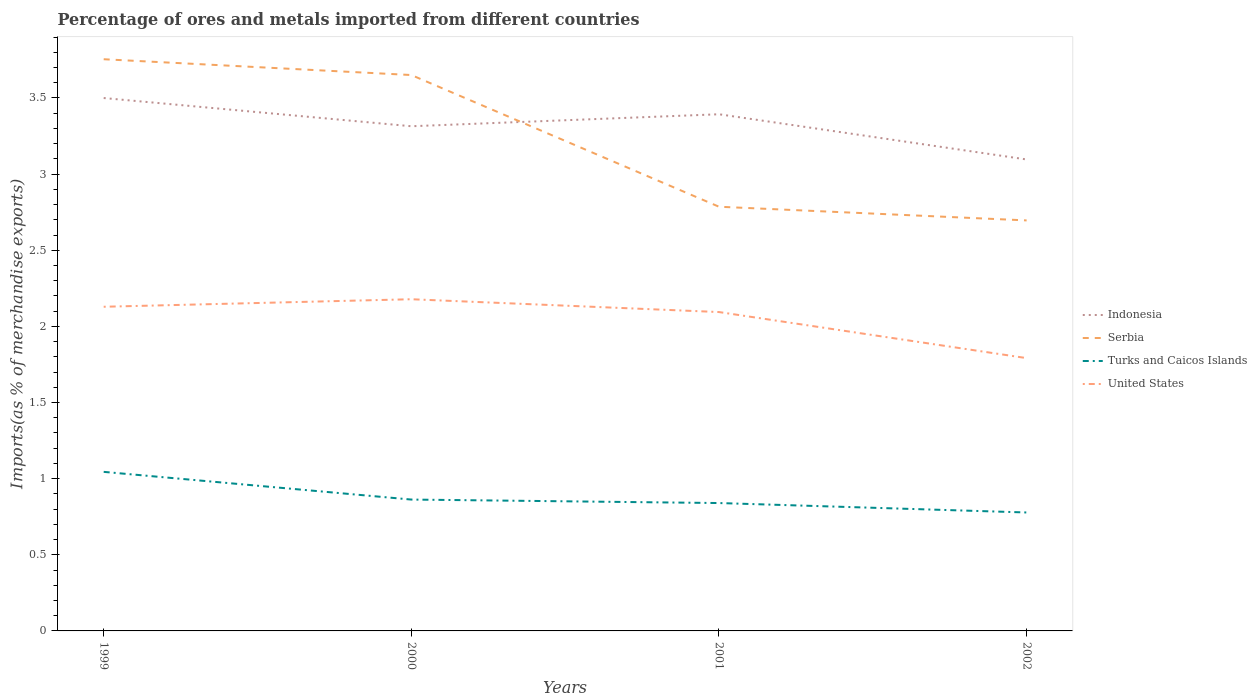How many different coloured lines are there?
Ensure brevity in your answer.  4. Does the line corresponding to Indonesia intersect with the line corresponding to Turks and Caicos Islands?
Your answer should be compact. No. Across all years, what is the maximum percentage of imports to different countries in United States?
Keep it short and to the point. 1.79. In which year was the percentage of imports to different countries in Serbia maximum?
Ensure brevity in your answer.  2002. What is the total percentage of imports to different countries in Turks and Caicos Islands in the graph?
Provide a succinct answer. 0.27. What is the difference between the highest and the second highest percentage of imports to different countries in Serbia?
Offer a terse response. 1.06. How many lines are there?
Offer a very short reply. 4. What is the difference between two consecutive major ticks on the Y-axis?
Provide a succinct answer. 0.5. Are the values on the major ticks of Y-axis written in scientific E-notation?
Offer a terse response. No. Does the graph contain any zero values?
Your response must be concise. No. Does the graph contain grids?
Offer a terse response. No. Where does the legend appear in the graph?
Provide a succinct answer. Center right. What is the title of the graph?
Ensure brevity in your answer.  Percentage of ores and metals imported from different countries. Does "United Kingdom" appear as one of the legend labels in the graph?
Your response must be concise. No. What is the label or title of the X-axis?
Offer a very short reply. Years. What is the label or title of the Y-axis?
Give a very brief answer. Imports(as % of merchandise exports). What is the Imports(as % of merchandise exports) of Indonesia in 1999?
Keep it short and to the point. 3.5. What is the Imports(as % of merchandise exports) in Serbia in 1999?
Ensure brevity in your answer.  3.75. What is the Imports(as % of merchandise exports) in Turks and Caicos Islands in 1999?
Your answer should be very brief. 1.04. What is the Imports(as % of merchandise exports) of United States in 1999?
Give a very brief answer. 2.13. What is the Imports(as % of merchandise exports) of Indonesia in 2000?
Ensure brevity in your answer.  3.31. What is the Imports(as % of merchandise exports) in Serbia in 2000?
Make the answer very short. 3.65. What is the Imports(as % of merchandise exports) in Turks and Caicos Islands in 2000?
Your answer should be compact. 0.86. What is the Imports(as % of merchandise exports) in United States in 2000?
Your answer should be compact. 2.18. What is the Imports(as % of merchandise exports) in Indonesia in 2001?
Provide a short and direct response. 3.39. What is the Imports(as % of merchandise exports) of Serbia in 2001?
Make the answer very short. 2.79. What is the Imports(as % of merchandise exports) of Turks and Caicos Islands in 2001?
Provide a succinct answer. 0.84. What is the Imports(as % of merchandise exports) in United States in 2001?
Ensure brevity in your answer.  2.09. What is the Imports(as % of merchandise exports) of Indonesia in 2002?
Offer a terse response. 3.1. What is the Imports(as % of merchandise exports) of Serbia in 2002?
Offer a terse response. 2.7. What is the Imports(as % of merchandise exports) of Turks and Caicos Islands in 2002?
Ensure brevity in your answer.  0.78. What is the Imports(as % of merchandise exports) in United States in 2002?
Offer a very short reply. 1.79. Across all years, what is the maximum Imports(as % of merchandise exports) in Indonesia?
Your answer should be compact. 3.5. Across all years, what is the maximum Imports(as % of merchandise exports) in Serbia?
Make the answer very short. 3.75. Across all years, what is the maximum Imports(as % of merchandise exports) of Turks and Caicos Islands?
Ensure brevity in your answer.  1.04. Across all years, what is the maximum Imports(as % of merchandise exports) in United States?
Make the answer very short. 2.18. Across all years, what is the minimum Imports(as % of merchandise exports) in Indonesia?
Provide a short and direct response. 3.1. Across all years, what is the minimum Imports(as % of merchandise exports) in Serbia?
Give a very brief answer. 2.7. Across all years, what is the minimum Imports(as % of merchandise exports) in Turks and Caicos Islands?
Ensure brevity in your answer.  0.78. Across all years, what is the minimum Imports(as % of merchandise exports) in United States?
Your answer should be compact. 1.79. What is the total Imports(as % of merchandise exports) of Indonesia in the graph?
Provide a succinct answer. 13.3. What is the total Imports(as % of merchandise exports) in Serbia in the graph?
Make the answer very short. 12.89. What is the total Imports(as % of merchandise exports) of Turks and Caicos Islands in the graph?
Your answer should be very brief. 3.52. What is the total Imports(as % of merchandise exports) in United States in the graph?
Your answer should be compact. 8.19. What is the difference between the Imports(as % of merchandise exports) in Indonesia in 1999 and that in 2000?
Your response must be concise. 0.19. What is the difference between the Imports(as % of merchandise exports) in Serbia in 1999 and that in 2000?
Ensure brevity in your answer.  0.1. What is the difference between the Imports(as % of merchandise exports) of Turks and Caicos Islands in 1999 and that in 2000?
Give a very brief answer. 0.18. What is the difference between the Imports(as % of merchandise exports) in United States in 1999 and that in 2000?
Make the answer very short. -0.05. What is the difference between the Imports(as % of merchandise exports) of Indonesia in 1999 and that in 2001?
Your answer should be very brief. 0.11. What is the difference between the Imports(as % of merchandise exports) in Serbia in 1999 and that in 2001?
Offer a very short reply. 0.97. What is the difference between the Imports(as % of merchandise exports) in Turks and Caicos Islands in 1999 and that in 2001?
Your response must be concise. 0.2. What is the difference between the Imports(as % of merchandise exports) of United States in 1999 and that in 2001?
Provide a succinct answer. 0.03. What is the difference between the Imports(as % of merchandise exports) in Indonesia in 1999 and that in 2002?
Provide a short and direct response. 0.4. What is the difference between the Imports(as % of merchandise exports) of Serbia in 1999 and that in 2002?
Provide a short and direct response. 1.06. What is the difference between the Imports(as % of merchandise exports) in Turks and Caicos Islands in 1999 and that in 2002?
Your response must be concise. 0.27. What is the difference between the Imports(as % of merchandise exports) of United States in 1999 and that in 2002?
Your response must be concise. 0.34. What is the difference between the Imports(as % of merchandise exports) of Indonesia in 2000 and that in 2001?
Your response must be concise. -0.08. What is the difference between the Imports(as % of merchandise exports) in Serbia in 2000 and that in 2001?
Ensure brevity in your answer.  0.86. What is the difference between the Imports(as % of merchandise exports) of Turks and Caicos Islands in 2000 and that in 2001?
Provide a short and direct response. 0.02. What is the difference between the Imports(as % of merchandise exports) of United States in 2000 and that in 2001?
Offer a very short reply. 0.08. What is the difference between the Imports(as % of merchandise exports) in Indonesia in 2000 and that in 2002?
Provide a succinct answer. 0.22. What is the difference between the Imports(as % of merchandise exports) in Serbia in 2000 and that in 2002?
Your response must be concise. 0.95. What is the difference between the Imports(as % of merchandise exports) of Turks and Caicos Islands in 2000 and that in 2002?
Your answer should be very brief. 0.08. What is the difference between the Imports(as % of merchandise exports) in United States in 2000 and that in 2002?
Provide a short and direct response. 0.39. What is the difference between the Imports(as % of merchandise exports) of Indonesia in 2001 and that in 2002?
Your answer should be compact. 0.3. What is the difference between the Imports(as % of merchandise exports) of Serbia in 2001 and that in 2002?
Your response must be concise. 0.09. What is the difference between the Imports(as % of merchandise exports) of Turks and Caicos Islands in 2001 and that in 2002?
Give a very brief answer. 0.06. What is the difference between the Imports(as % of merchandise exports) of United States in 2001 and that in 2002?
Your answer should be compact. 0.3. What is the difference between the Imports(as % of merchandise exports) in Indonesia in 1999 and the Imports(as % of merchandise exports) in Serbia in 2000?
Keep it short and to the point. -0.15. What is the difference between the Imports(as % of merchandise exports) of Indonesia in 1999 and the Imports(as % of merchandise exports) of Turks and Caicos Islands in 2000?
Your answer should be compact. 2.64. What is the difference between the Imports(as % of merchandise exports) in Indonesia in 1999 and the Imports(as % of merchandise exports) in United States in 2000?
Your answer should be very brief. 1.32. What is the difference between the Imports(as % of merchandise exports) in Serbia in 1999 and the Imports(as % of merchandise exports) in Turks and Caicos Islands in 2000?
Keep it short and to the point. 2.89. What is the difference between the Imports(as % of merchandise exports) in Serbia in 1999 and the Imports(as % of merchandise exports) in United States in 2000?
Ensure brevity in your answer.  1.58. What is the difference between the Imports(as % of merchandise exports) of Turks and Caicos Islands in 1999 and the Imports(as % of merchandise exports) of United States in 2000?
Your answer should be very brief. -1.13. What is the difference between the Imports(as % of merchandise exports) in Indonesia in 1999 and the Imports(as % of merchandise exports) in Serbia in 2001?
Give a very brief answer. 0.71. What is the difference between the Imports(as % of merchandise exports) in Indonesia in 1999 and the Imports(as % of merchandise exports) in Turks and Caicos Islands in 2001?
Give a very brief answer. 2.66. What is the difference between the Imports(as % of merchandise exports) of Indonesia in 1999 and the Imports(as % of merchandise exports) of United States in 2001?
Your answer should be very brief. 1.41. What is the difference between the Imports(as % of merchandise exports) in Serbia in 1999 and the Imports(as % of merchandise exports) in Turks and Caicos Islands in 2001?
Offer a terse response. 2.91. What is the difference between the Imports(as % of merchandise exports) of Serbia in 1999 and the Imports(as % of merchandise exports) of United States in 2001?
Your response must be concise. 1.66. What is the difference between the Imports(as % of merchandise exports) of Turks and Caicos Islands in 1999 and the Imports(as % of merchandise exports) of United States in 2001?
Make the answer very short. -1.05. What is the difference between the Imports(as % of merchandise exports) in Indonesia in 1999 and the Imports(as % of merchandise exports) in Serbia in 2002?
Keep it short and to the point. 0.8. What is the difference between the Imports(as % of merchandise exports) of Indonesia in 1999 and the Imports(as % of merchandise exports) of Turks and Caicos Islands in 2002?
Make the answer very short. 2.72. What is the difference between the Imports(as % of merchandise exports) in Indonesia in 1999 and the Imports(as % of merchandise exports) in United States in 2002?
Give a very brief answer. 1.71. What is the difference between the Imports(as % of merchandise exports) of Serbia in 1999 and the Imports(as % of merchandise exports) of Turks and Caicos Islands in 2002?
Keep it short and to the point. 2.98. What is the difference between the Imports(as % of merchandise exports) of Serbia in 1999 and the Imports(as % of merchandise exports) of United States in 2002?
Provide a short and direct response. 1.96. What is the difference between the Imports(as % of merchandise exports) of Turks and Caicos Islands in 1999 and the Imports(as % of merchandise exports) of United States in 2002?
Your answer should be very brief. -0.75. What is the difference between the Imports(as % of merchandise exports) of Indonesia in 2000 and the Imports(as % of merchandise exports) of Serbia in 2001?
Provide a short and direct response. 0.53. What is the difference between the Imports(as % of merchandise exports) of Indonesia in 2000 and the Imports(as % of merchandise exports) of Turks and Caicos Islands in 2001?
Keep it short and to the point. 2.47. What is the difference between the Imports(as % of merchandise exports) in Indonesia in 2000 and the Imports(as % of merchandise exports) in United States in 2001?
Your answer should be very brief. 1.22. What is the difference between the Imports(as % of merchandise exports) in Serbia in 2000 and the Imports(as % of merchandise exports) in Turks and Caicos Islands in 2001?
Provide a short and direct response. 2.81. What is the difference between the Imports(as % of merchandise exports) in Serbia in 2000 and the Imports(as % of merchandise exports) in United States in 2001?
Give a very brief answer. 1.56. What is the difference between the Imports(as % of merchandise exports) in Turks and Caicos Islands in 2000 and the Imports(as % of merchandise exports) in United States in 2001?
Your response must be concise. -1.23. What is the difference between the Imports(as % of merchandise exports) of Indonesia in 2000 and the Imports(as % of merchandise exports) of Serbia in 2002?
Provide a succinct answer. 0.62. What is the difference between the Imports(as % of merchandise exports) in Indonesia in 2000 and the Imports(as % of merchandise exports) in Turks and Caicos Islands in 2002?
Ensure brevity in your answer.  2.54. What is the difference between the Imports(as % of merchandise exports) in Indonesia in 2000 and the Imports(as % of merchandise exports) in United States in 2002?
Make the answer very short. 1.52. What is the difference between the Imports(as % of merchandise exports) in Serbia in 2000 and the Imports(as % of merchandise exports) in Turks and Caicos Islands in 2002?
Ensure brevity in your answer.  2.87. What is the difference between the Imports(as % of merchandise exports) of Serbia in 2000 and the Imports(as % of merchandise exports) of United States in 2002?
Ensure brevity in your answer.  1.86. What is the difference between the Imports(as % of merchandise exports) in Turks and Caicos Islands in 2000 and the Imports(as % of merchandise exports) in United States in 2002?
Ensure brevity in your answer.  -0.93. What is the difference between the Imports(as % of merchandise exports) in Indonesia in 2001 and the Imports(as % of merchandise exports) in Serbia in 2002?
Your response must be concise. 0.7. What is the difference between the Imports(as % of merchandise exports) of Indonesia in 2001 and the Imports(as % of merchandise exports) of Turks and Caicos Islands in 2002?
Ensure brevity in your answer.  2.62. What is the difference between the Imports(as % of merchandise exports) in Indonesia in 2001 and the Imports(as % of merchandise exports) in United States in 2002?
Your answer should be compact. 1.6. What is the difference between the Imports(as % of merchandise exports) in Serbia in 2001 and the Imports(as % of merchandise exports) in Turks and Caicos Islands in 2002?
Offer a very short reply. 2.01. What is the difference between the Imports(as % of merchandise exports) in Turks and Caicos Islands in 2001 and the Imports(as % of merchandise exports) in United States in 2002?
Give a very brief answer. -0.95. What is the average Imports(as % of merchandise exports) in Indonesia per year?
Keep it short and to the point. 3.33. What is the average Imports(as % of merchandise exports) of Serbia per year?
Offer a very short reply. 3.22. What is the average Imports(as % of merchandise exports) of Turks and Caicos Islands per year?
Your answer should be compact. 0.88. What is the average Imports(as % of merchandise exports) in United States per year?
Your answer should be compact. 2.05. In the year 1999, what is the difference between the Imports(as % of merchandise exports) of Indonesia and Imports(as % of merchandise exports) of Serbia?
Make the answer very short. -0.25. In the year 1999, what is the difference between the Imports(as % of merchandise exports) of Indonesia and Imports(as % of merchandise exports) of Turks and Caicos Islands?
Offer a very short reply. 2.46. In the year 1999, what is the difference between the Imports(as % of merchandise exports) of Indonesia and Imports(as % of merchandise exports) of United States?
Offer a very short reply. 1.37. In the year 1999, what is the difference between the Imports(as % of merchandise exports) in Serbia and Imports(as % of merchandise exports) in Turks and Caicos Islands?
Provide a succinct answer. 2.71. In the year 1999, what is the difference between the Imports(as % of merchandise exports) in Serbia and Imports(as % of merchandise exports) in United States?
Offer a very short reply. 1.63. In the year 1999, what is the difference between the Imports(as % of merchandise exports) in Turks and Caicos Islands and Imports(as % of merchandise exports) in United States?
Your response must be concise. -1.08. In the year 2000, what is the difference between the Imports(as % of merchandise exports) in Indonesia and Imports(as % of merchandise exports) in Serbia?
Offer a terse response. -0.34. In the year 2000, what is the difference between the Imports(as % of merchandise exports) in Indonesia and Imports(as % of merchandise exports) in Turks and Caicos Islands?
Keep it short and to the point. 2.45. In the year 2000, what is the difference between the Imports(as % of merchandise exports) of Indonesia and Imports(as % of merchandise exports) of United States?
Ensure brevity in your answer.  1.14. In the year 2000, what is the difference between the Imports(as % of merchandise exports) of Serbia and Imports(as % of merchandise exports) of Turks and Caicos Islands?
Provide a succinct answer. 2.79. In the year 2000, what is the difference between the Imports(as % of merchandise exports) in Serbia and Imports(as % of merchandise exports) in United States?
Offer a terse response. 1.47. In the year 2000, what is the difference between the Imports(as % of merchandise exports) in Turks and Caicos Islands and Imports(as % of merchandise exports) in United States?
Provide a succinct answer. -1.32. In the year 2001, what is the difference between the Imports(as % of merchandise exports) of Indonesia and Imports(as % of merchandise exports) of Serbia?
Provide a short and direct response. 0.61. In the year 2001, what is the difference between the Imports(as % of merchandise exports) of Indonesia and Imports(as % of merchandise exports) of Turks and Caicos Islands?
Give a very brief answer. 2.55. In the year 2001, what is the difference between the Imports(as % of merchandise exports) in Indonesia and Imports(as % of merchandise exports) in United States?
Provide a short and direct response. 1.3. In the year 2001, what is the difference between the Imports(as % of merchandise exports) of Serbia and Imports(as % of merchandise exports) of Turks and Caicos Islands?
Offer a terse response. 1.95. In the year 2001, what is the difference between the Imports(as % of merchandise exports) in Serbia and Imports(as % of merchandise exports) in United States?
Your response must be concise. 0.69. In the year 2001, what is the difference between the Imports(as % of merchandise exports) in Turks and Caicos Islands and Imports(as % of merchandise exports) in United States?
Offer a terse response. -1.25. In the year 2002, what is the difference between the Imports(as % of merchandise exports) of Indonesia and Imports(as % of merchandise exports) of Serbia?
Keep it short and to the point. 0.4. In the year 2002, what is the difference between the Imports(as % of merchandise exports) of Indonesia and Imports(as % of merchandise exports) of Turks and Caicos Islands?
Offer a very short reply. 2.32. In the year 2002, what is the difference between the Imports(as % of merchandise exports) of Indonesia and Imports(as % of merchandise exports) of United States?
Provide a short and direct response. 1.3. In the year 2002, what is the difference between the Imports(as % of merchandise exports) in Serbia and Imports(as % of merchandise exports) in Turks and Caicos Islands?
Make the answer very short. 1.92. In the year 2002, what is the difference between the Imports(as % of merchandise exports) of Serbia and Imports(as % of merchandise exports) of United States?
Your answer should be very brief. 0.9. In the year 2002, what is the difference between the Imports(as % of merchandise exports) of Turks and Caicos Islands and Imports(as % of merchandise exports) of United States?
Provide a succinct answer. -1.01. What is the ratio of the Imports(as % of merchandise exports) of Indonesia in 1999 to that in 2000?
Make the answer very short. 1.06. What is the ratio of the Imports(as % of merchandise exports) of Serbia in 1999 to that in 2000?
Provide a short and direct response. 1.03. What is the ratio of the Imports(as % of merchandise exports) in Turks and Caicos Islands in 1999 to that in 2000?
Offer a terse response. 1.21. What is the ratio of the Imports(as % of merchandise exports) in United States in 1999 to that in 2000?
Your response must be concise. 0.98. What is the ratio of the Imports(as % of merchandise exports) of Indonesia in 1999 to that in 2001?
Give a very brief answer. 1.03. What is the ratio of the Imports(as % of merchandise exports) in Serbia in 1999 to that in 2001?
Give a very brief answer. 1.35. What is the ratio of the Imports(as % of merchandise exports) in Turks and Caicos Islands in 1999 to that in 2001?
Your answer should be compact. 1.24. What is the ratio of the Imports(as % of merchandise exports) in United States in 1999 to that in 2001?
Your response must be concise. 1.02. What is the ratio of the Imports(as % of merchandise exports) in Indonesia in 1999 to that in 2002?
Offer a very short reply. 1.13. What is the ratio of the Imports(as % of merchandise exports) in Serbia in 1999 to that in 2002?
Keep it short and to the point. 1.39. What is the ratio of the Imports(as % of merchandise exports) of Turks and Caicos Islands in 1999 to that in 2002?
Keep it short and to the point. 1.34. What is the ratio of the Imports(as % of merchandise exports) in United States in 1999 to that in 2002?
Ensure brevity in your answer.  1.19. What is the ratio of the Imports(as % of merchandise exports) of Indonesia in 2000 to that in 2001?
Offer a very short reply. 0.98. What is the ratio of the Imports(as % of merchandise exports) in Serbia in 2000 to that in 2001?
Make the answer very short. 1.31. What is the ratio of the Imports(as % of merchandise exports) of Turks and Caicos Islands in 2000 to that in 2001?
Keep it short and to the point. 1.03. What is the ratio of the Imports(as % of merchandise exports) of United States in 2000 to that in 2001?
Keep it short and to the point. 1.04. What is the ratio of the Imports(as % of merchandise exports) of Indonesia in 2000 to that in 2002?
Your answer should be compact. 1.07. What is the ratio of the Imports(as % of merchandise exports) in Serbia in 2000 to that in 2002?
Your answer should be compact. 1.35. What is the ratio of the Imports(as % of merchandise exports) in Turks and Caicos Islands in 2000 to that in 2002?
Keep it short and to the point. 1.11. What is the ratio of the Imports(as % of merchandise exports) of United States in 2000 to that in 2002?
Give a very brief answer. 1.22. What is the ratio of the Imports(as % of merchandise exports) in Indonesia in 2001 to that in 2002?
Offer a very short reply. 1.1. What is the ratio of the Imports(as % of merchandise exports) in Turks and Caicos Islands in 2001 to that in 2002?
Make the answer very short. 1.08. What is the ratio of the Imports(as % of merchandise exports) of United States in 2001 to that in 2002?
Offer a very short reply. 1.17. What is the difference between the highest and the second highest Imports(as % of merchandise exports) of Indonesia?
Offer a terse response. 0.11. What is the difference between the highest and the second highest Imports(as % of merchandise exports) in Serbia?
Offer a terse response. 0.1. What is the difference between the highest and the second highest Imports(as % of merchandise exports) in Turks and Caicos Islands?
Provide a succinct answer. 0.18. What is the difference between the highest and the second highest Imports(as % of merchandise exports) of United States?
Make the answer very short. 0.05. What is the difference between the highest and the lowest Imports(as % of merchandise exports) of Indonesia?
Ensure brevity in your answer.  0.4. What is the difference between the highest and the lowest Imports(as % of merchandise exports) of Serbia?
Keep it short and to the point. 1.06. What is the difference between the highest and the lowest Imports(as % of merchandise exports) in Turks and Caicos Islands?
Provide a succinct answer. 0.27. What is the difference between the highest and the lowest Imports(as % of merchandise exports) of United States?
Provide a succinct answer. 0.39. 